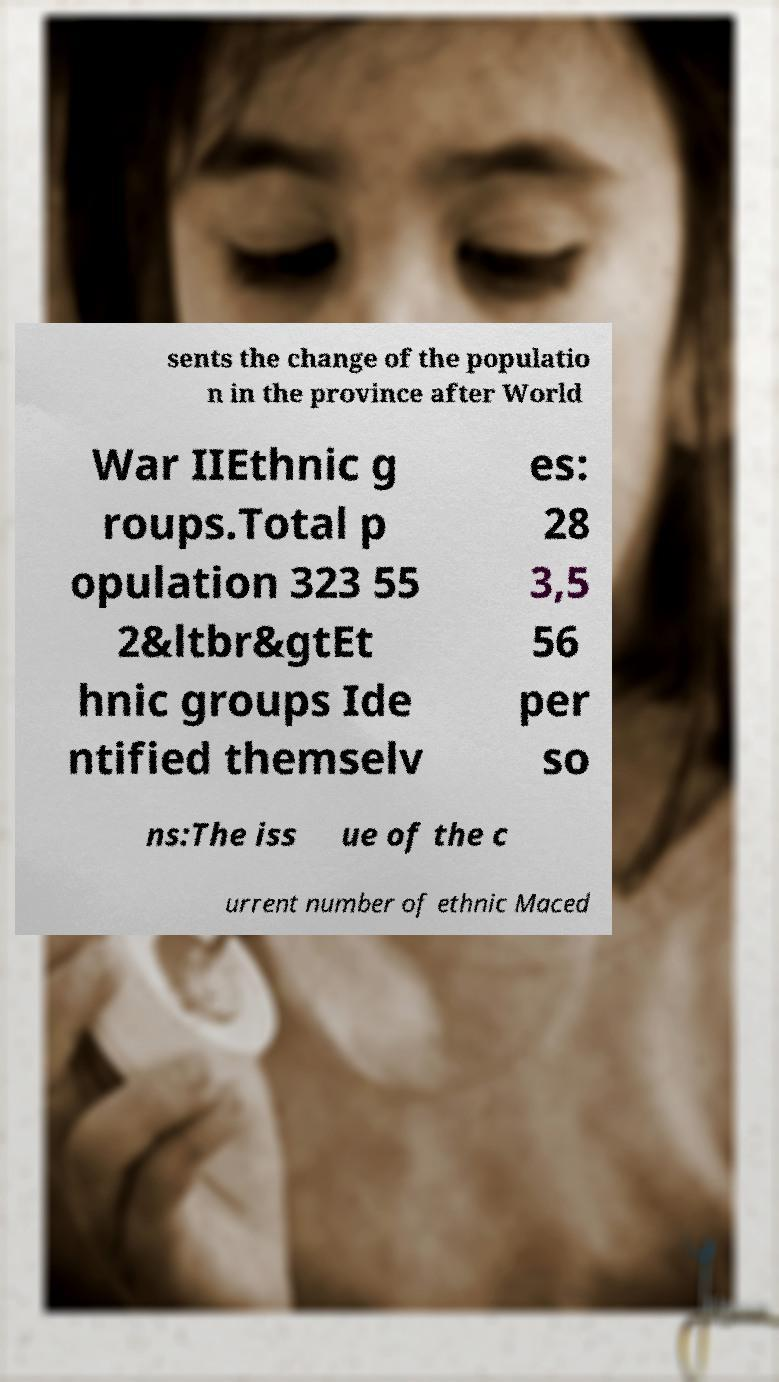Can you read and provide the text displayed in the image?This photo seems to have some interesting text. Can you extract and type it out for me? sents the change of the populatio n in the province after World War IIEthnic g roups.Total p opulation 323 55 2&ltbr&gtEt hnic groups Ide ntified themselv es: 28 3,5 56 per so ns:The iss ue of the c urrent number of ethnic Maced 